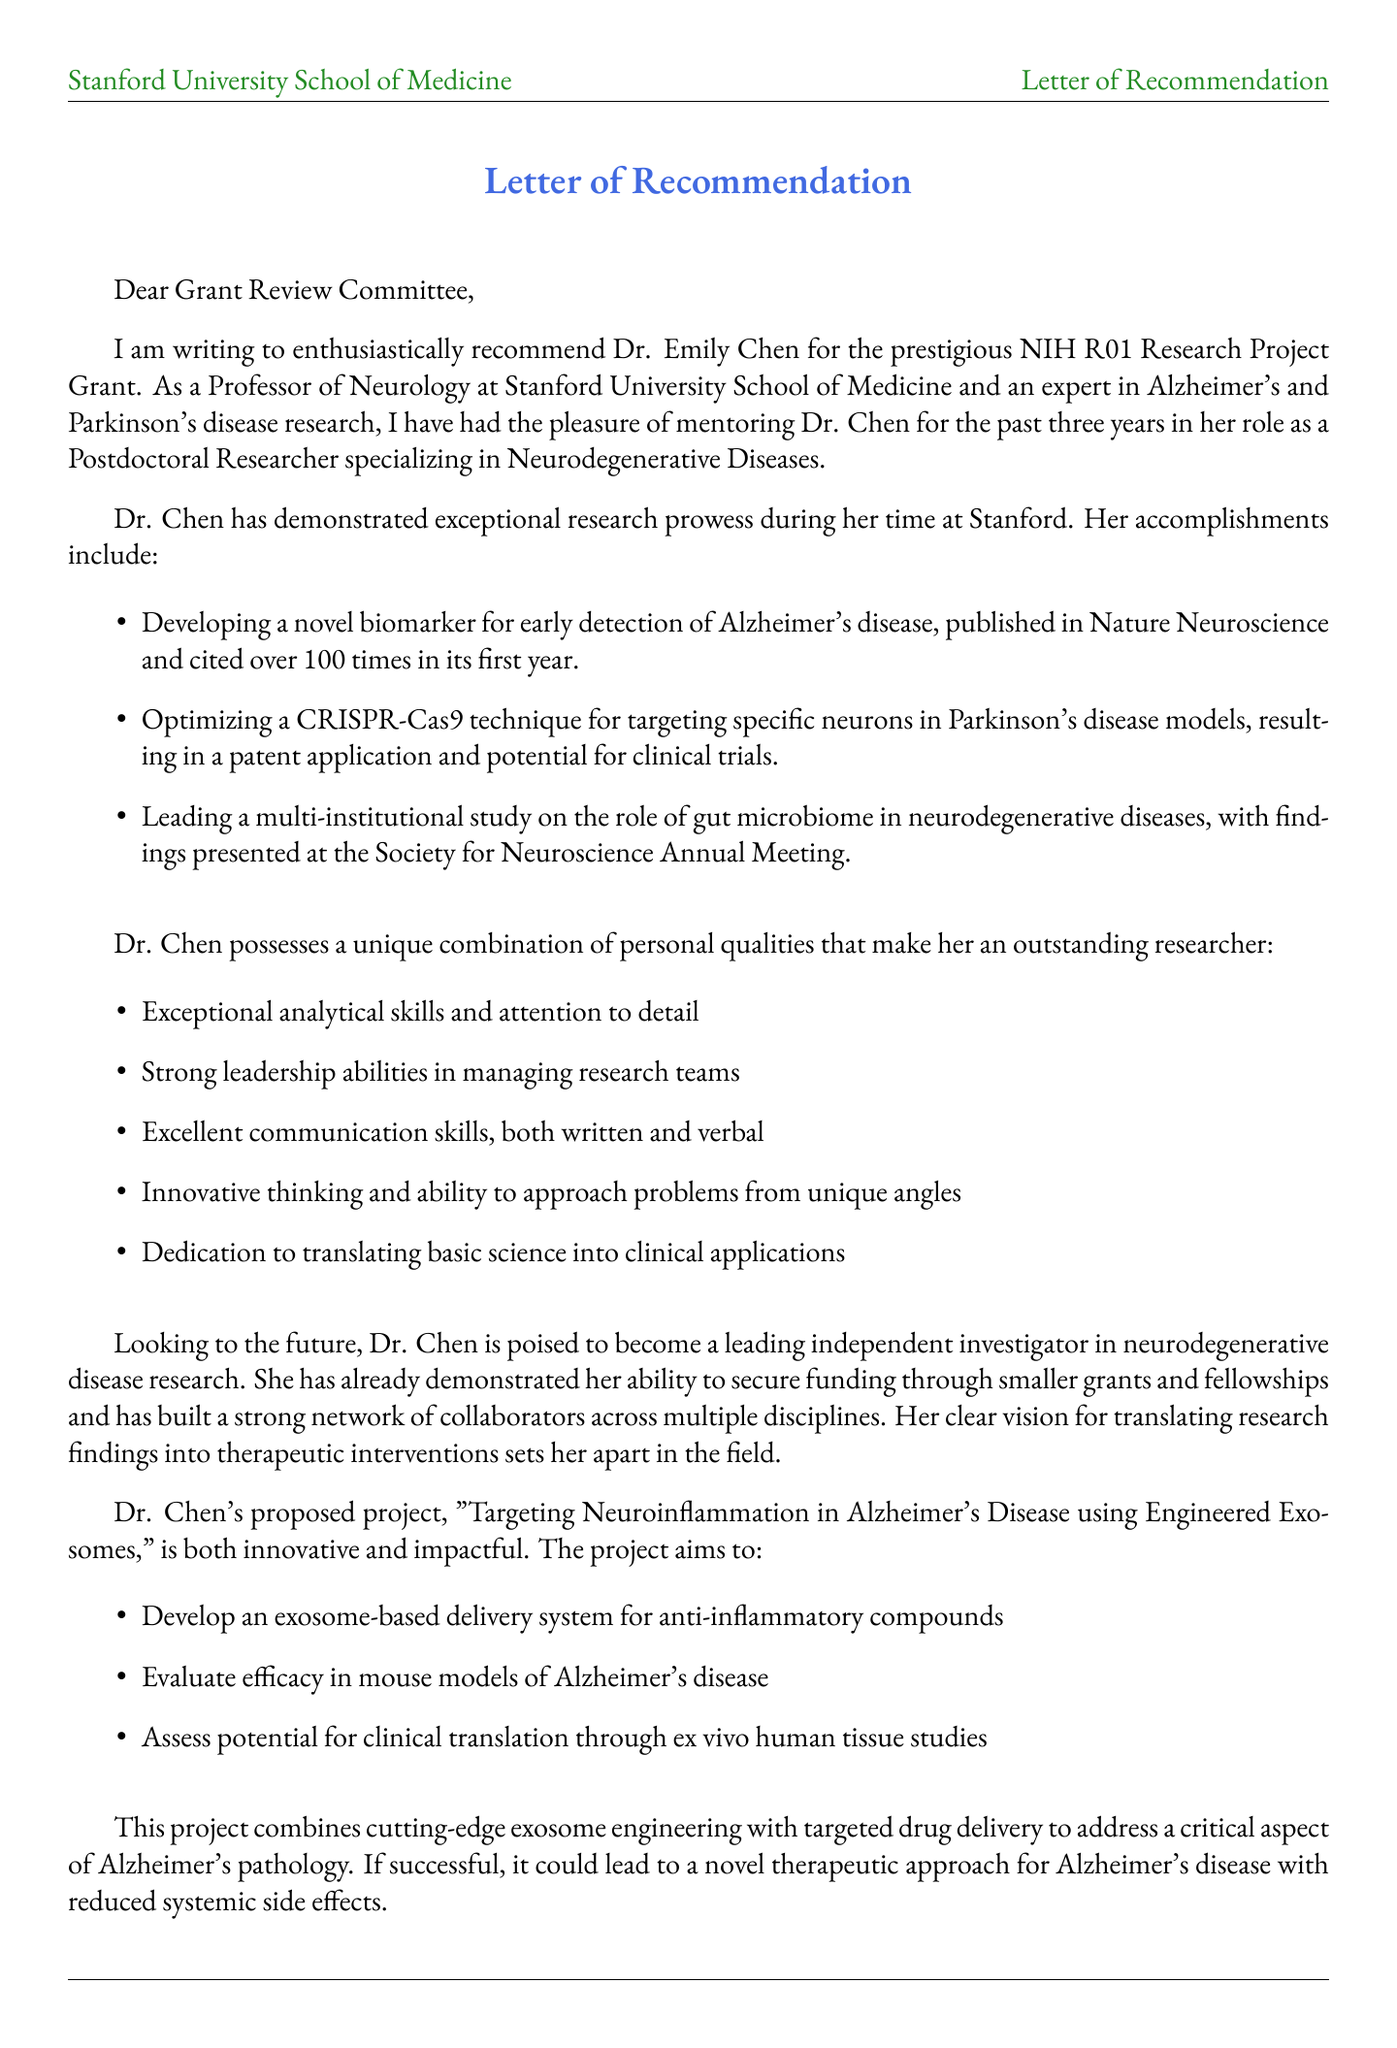What is the name of the researcher recommended? The document states that the researcher being recommended is Dr. Emily Chen.
Answer: Dr. Emily Chen Who is the mentor of the researcher? The document specifies that Dr. Michael J. Thompson is the mentor.
Answer: Dr. Michael J. Thompson What is the grant name being applied for? The document indicates that the grant is the NIH R01 Research Project Grant.
Answer: NIH R01 Research Project Grant How many years has the researcher worked with the mentor? The document mentions that Dr. Emily Chen has worked with her mentor for 3 years.
Answer: 3 What is the main objective of the proposed project? The document lists several objectives, but the primary focus is on developing an exosome-based delivery system for anti-inflammatory compounds.
Answer: Develop exosome-based delivery system for anti-inflammatory compounds What journal published the paper on novel biomarkers? The document states that the paper was published in Nature Neuroscience.
Answer: Nature Neuroscience How many research accomplishments are listed in the letter? The document enumerates three specific research accomplishments for Dr. Chen.
Answer: 3 What specific field does the researcher specialize in? The document reveals that Dr. Emily Chen specializes in Neurodegenerative Diseases.
Answer: Neurodegenerative Diseases What quality is highlighted regarding the researcher's communication skills? The document describes the researcher's communication skills as excellent, both written and verbal.
Answer: Excellent communication skills, both written and verbal 